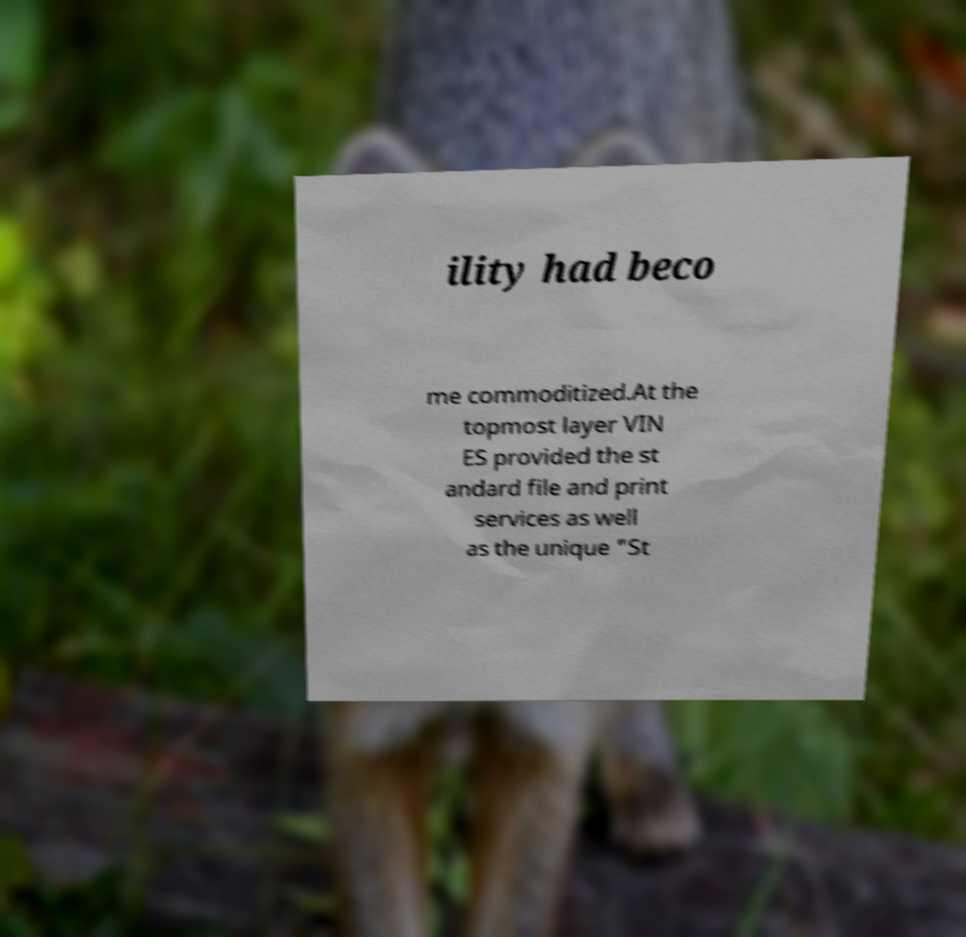Can you read and provide the text displayed in the image?This photo seems to have some interesting text. Can you extract and type it out for me? ility had beco me commoditized.At the topmost layer VIN ES provided the st andard file and print services as well as the unique "St 